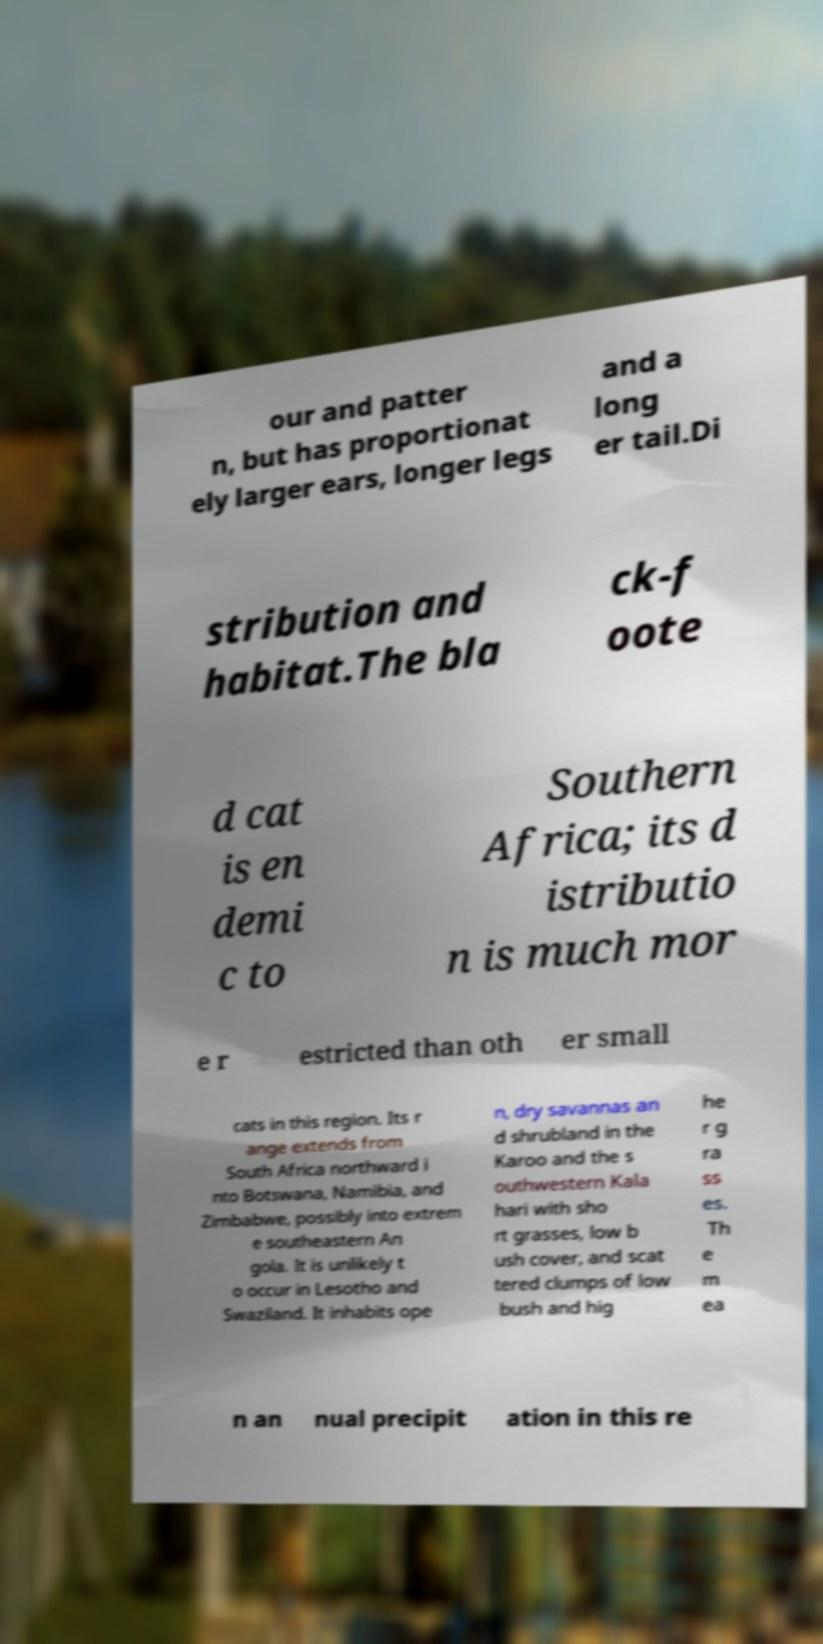Please identify and transcribe the text found in this image. our and patter n, but has proportionat ely larger ears, longer legs and a long er tail.Di stribution and habitat.The bla ck-f oote d cat is en demi c to Southern Africa; its d istributio n is much mor e r estricted than oth er small cats in this region. Its r ange extends from South Africa northward i nto Botswana, Namibia, and Zimbabwe, possibly into extrem e southeastern An gola. It is unlikely t o occur in Lesotho and Swaziland. It inhabits ope n, dry savannas an d shrubland in the Karoo and the s outhwestern Kala hari with sho rt grasses, low b ush cover, and scat tered clumps of low bush and hig he r g ra ss es. Th e m ea n an nual precipit ation in this re 